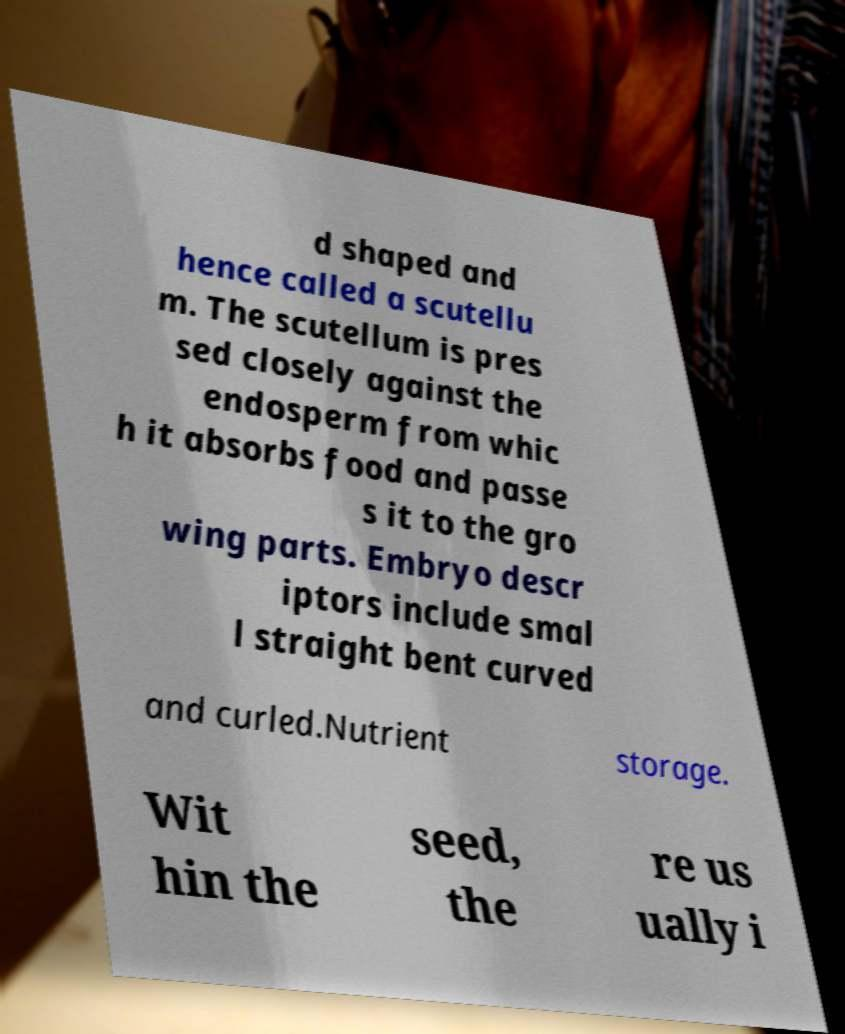What messages or text are displayed in this image? I need them in a readable, typed format. d shaped and hence called a scutellu m. The scutellum is pres sed closely against the endosperm from whic h it absorbs food and passe s it to the gro wing parts. Embryo descr iptors include smal l straight bent curved and curled.Nutrient storage. Wit hin the seed, the re us ually i 